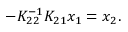<formula> <loc_0><loc_0><loc_500><loc_500>- K _ { 2 2 } ^ { - 1 } K _ { 2 1 } x _ { 1 } = x _ { 2 } .</formula> 